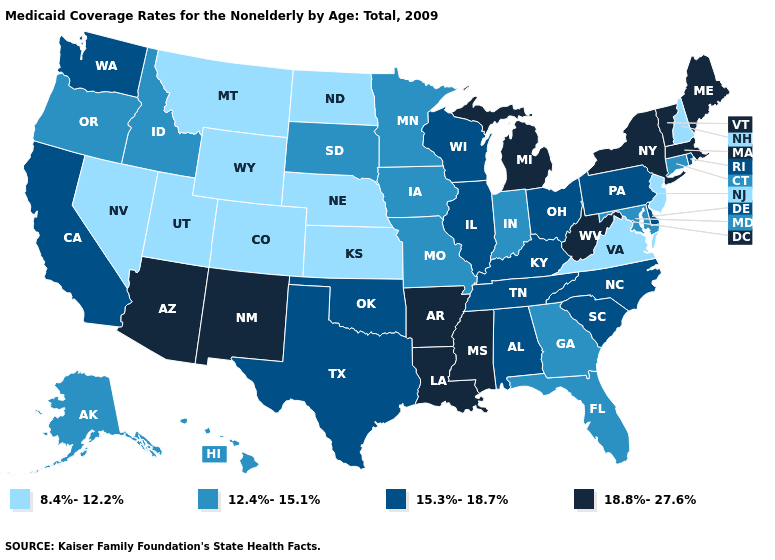Name the states that have a value in the range 15.3%-18.7%?
Be succinct. Alabama, California, Delaware, Illinois, Kentucky, North Carolina, Ohio, Oklahoma, Pennsylvania, Rhode Island, South Carolina, Tennessee, Texas, Washington, Wisconsin. What is the value of Hawaii?
Answer briefly. 12.4%-15.1%. How many symbols are there in the legend?
Concise answer only. 4. Does Alaska have a lower value than Vermont?
Concise answer only. Yes. Name the states that have a value in the range 8.4%-12.2%?
Give a very brief answer. Colorado, Kansas, Montana, Nebraska, Nevada, New Hampshire, New Jersey, North Dakota, Utah, Virginia, Wyoming. What is the value of South Dakota?
Short answer required. 12.4%-15.1%. Among the states that border Iowa , does Illinois have the highest value?
Short answer required. Yes. Which states have the lowest value in the South?
Give a very brief answer. Virginia. Name the states that have a value in the range 12.4%-15.1%?
Be succinct. Alaska, Connecticut, Florida, Georgia, Hawaii, Idaho, Indiana, Iowa, Maryland, Minnesota, Missouri, Oregon, South Dakota. Does Rhode Island have a lower value than Massachusetts?
Quick response, please. Yes. What is the highest value in the West ?
Give a very brief answer. 18.8%-27.6%. Name the states that have a value in the range 8.4%-12.2%?
Keep it brief. Colorado, Kansas, Montana, Nebraska, Nevada, New Hampshire, New Jersey, North Dakota, Utah, Virginia, Wyoming. Does Arizona have a higher value than Arkansas?
Quick response, please. No. What is the value of Vermont?
Short answer required. 18.8%-27.6%. Which states have the lowest value in the West?
Quick response, please. Colorado, Montana, Nevada, Utah, Wyoming. 